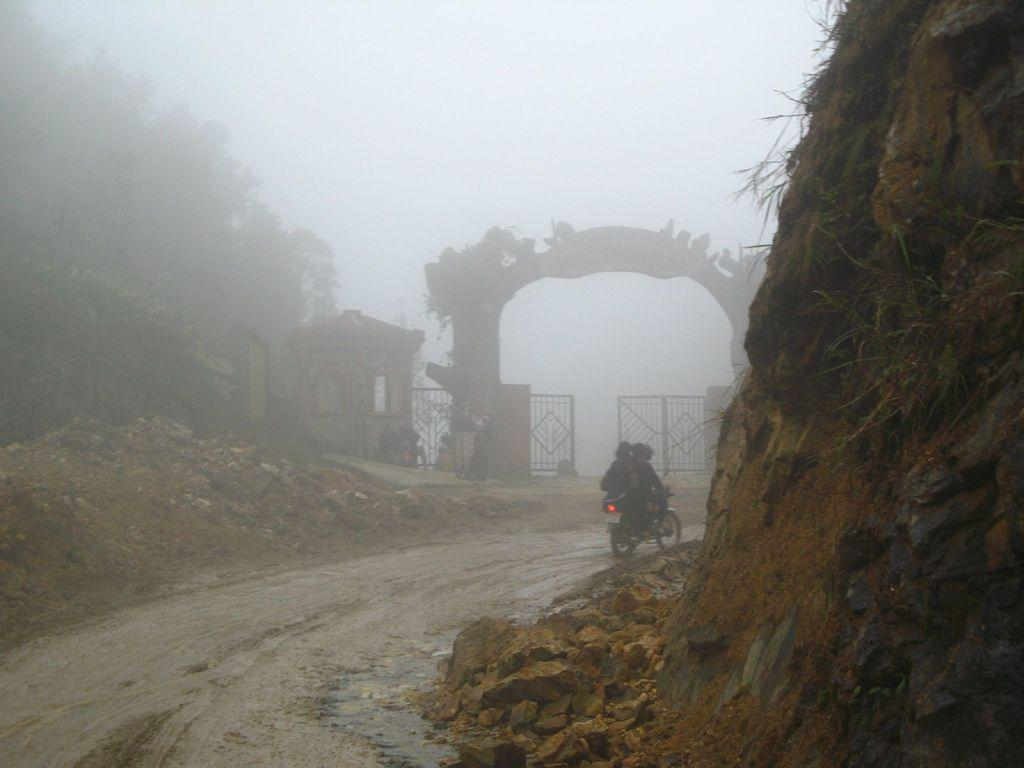How many people are in the image? There are two persons in the image. What are the two persons doing in the image? The two persons are sitting on a bike. What can be seen in the background of the image? There are gates, trees, a road, and the sky visible in the background of the image. What type of polish is being applied to the bike in the image? There is no indication in the image that any polish is being applied to the bike. How many babies are visible in the image? There are no babies present in the image. 